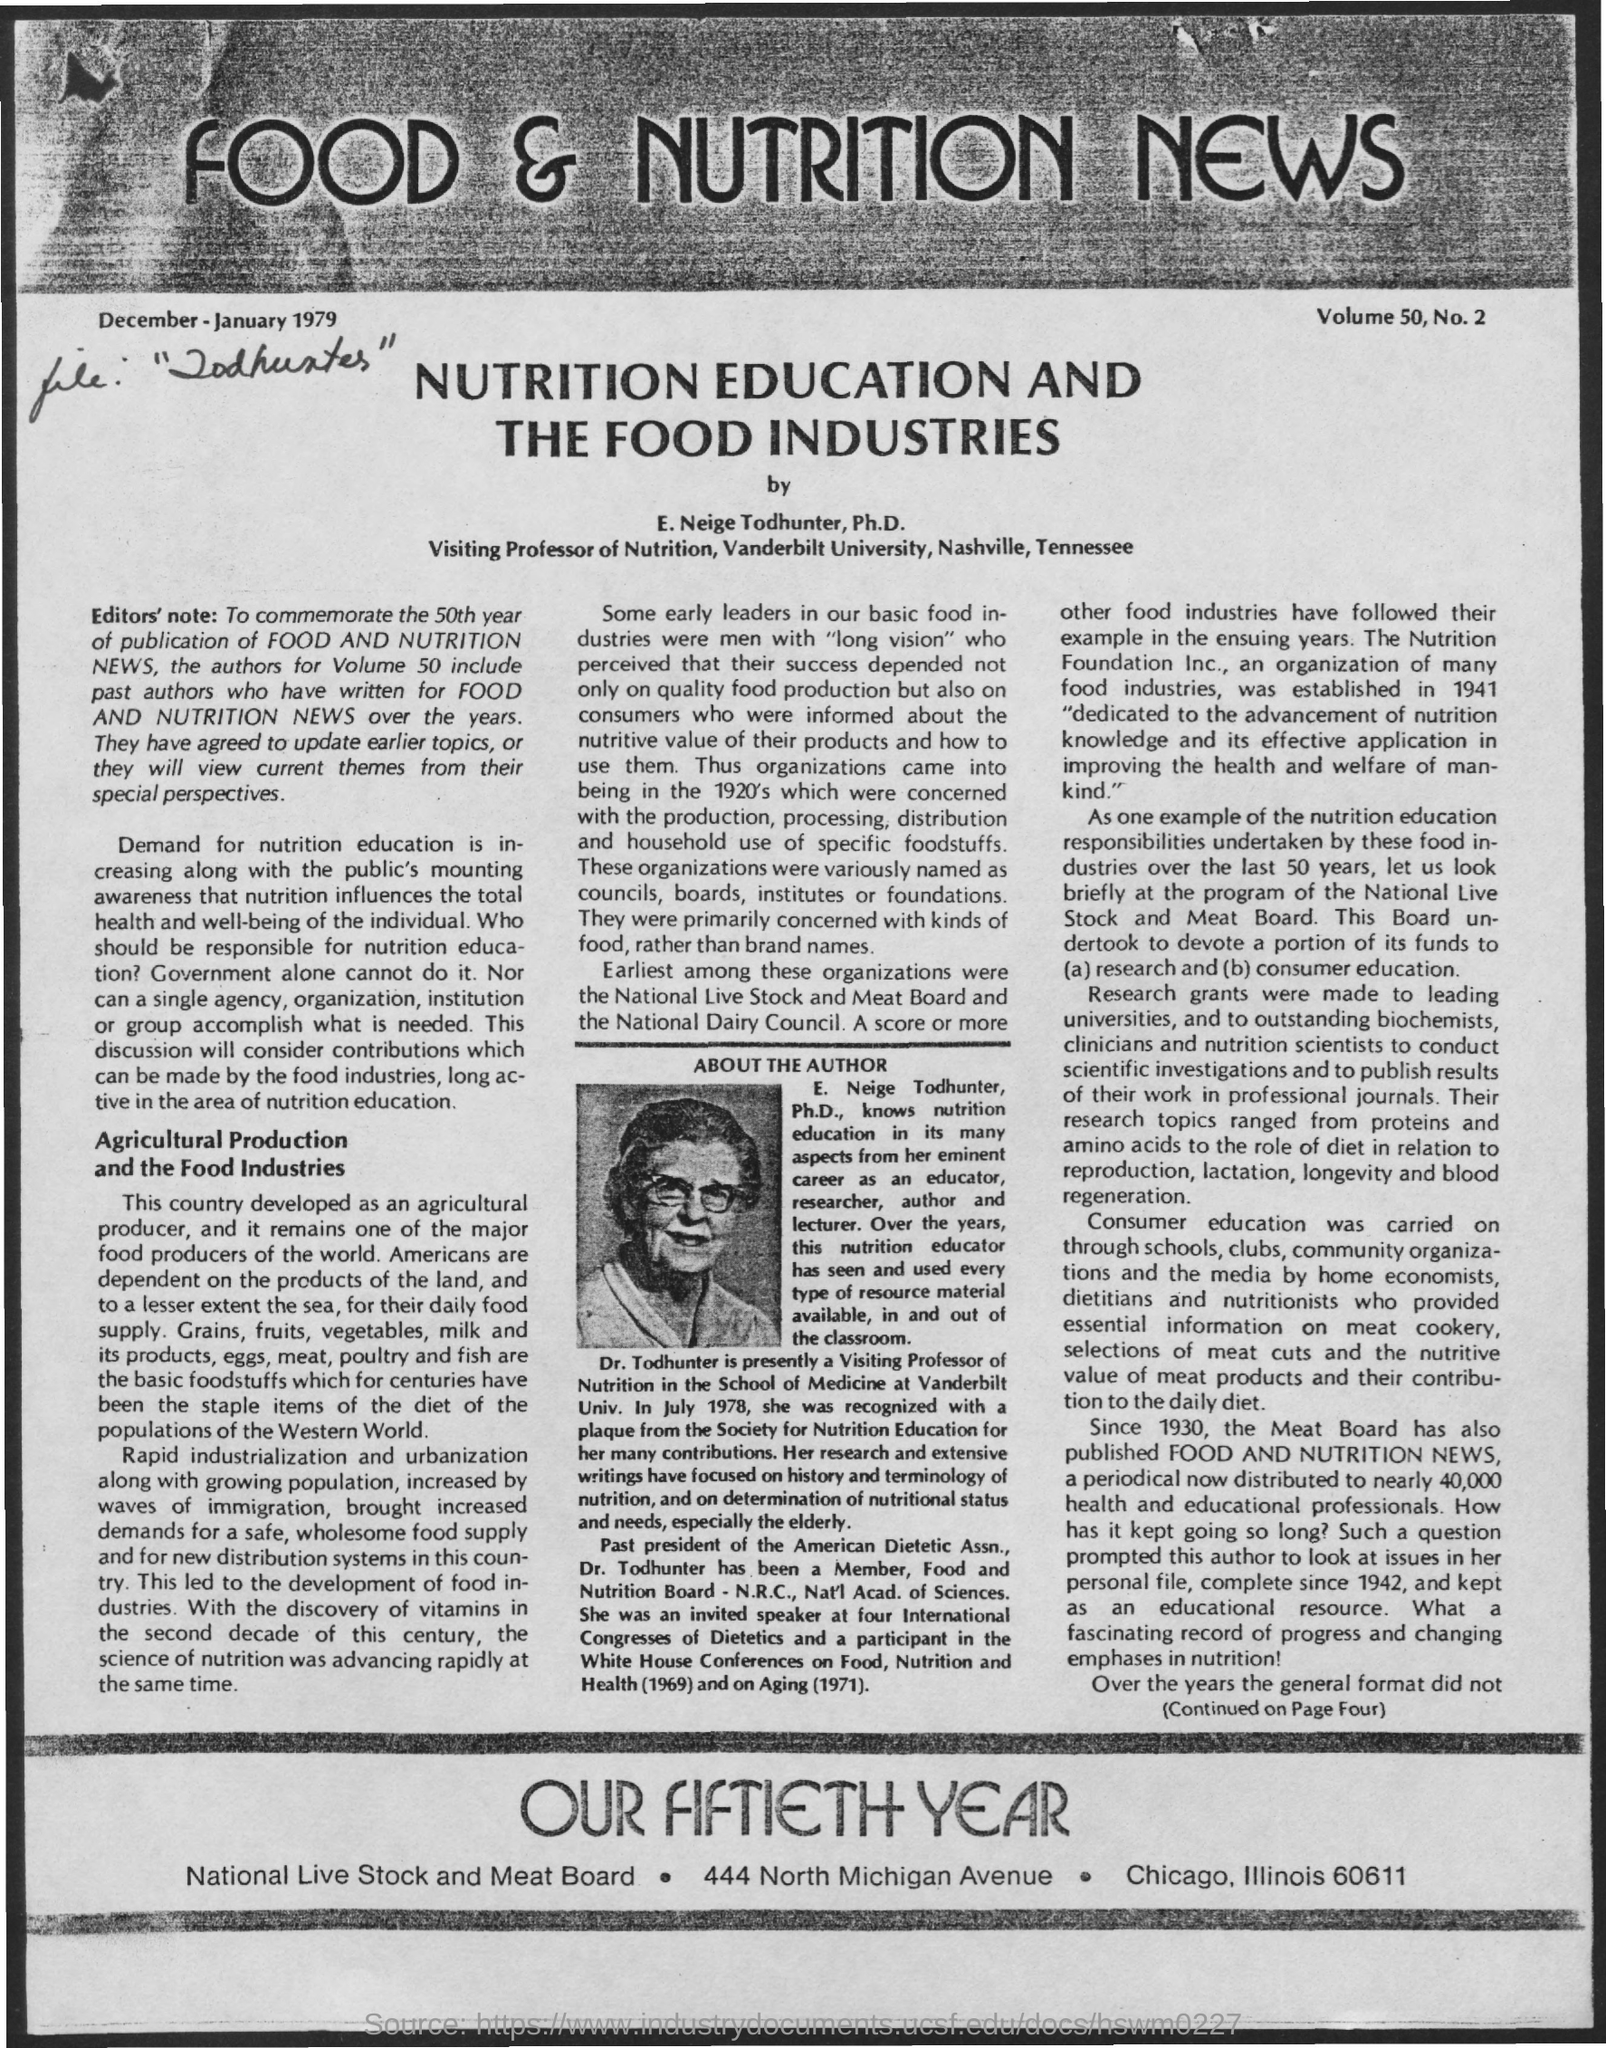What is the name of the author ?
Your answer should be very brief. E. Neige Todhunter. What is the name of the university mentioned ?
Provide a short and direct response. Vanderbilt University. What is the designation of e. neige todhunter ?
Make the answer very short. Visiting Professor of Nutrition. 